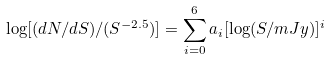Convert formula to latex. <formula><loc_0><loc_0><loc_500><loc_500>\log [ ( d N / d S ) / ( S ^ { - 2 . 5 } ) ] = \sum _ { i = 0 } ^ { 6 } a _ { i } [ \log ( S / m J y ) ] ^ { i }</formula> 